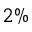Convert formula to latex. <formula><loc_0><loc_0><loc_500><loc_500>2 \%</formula> 